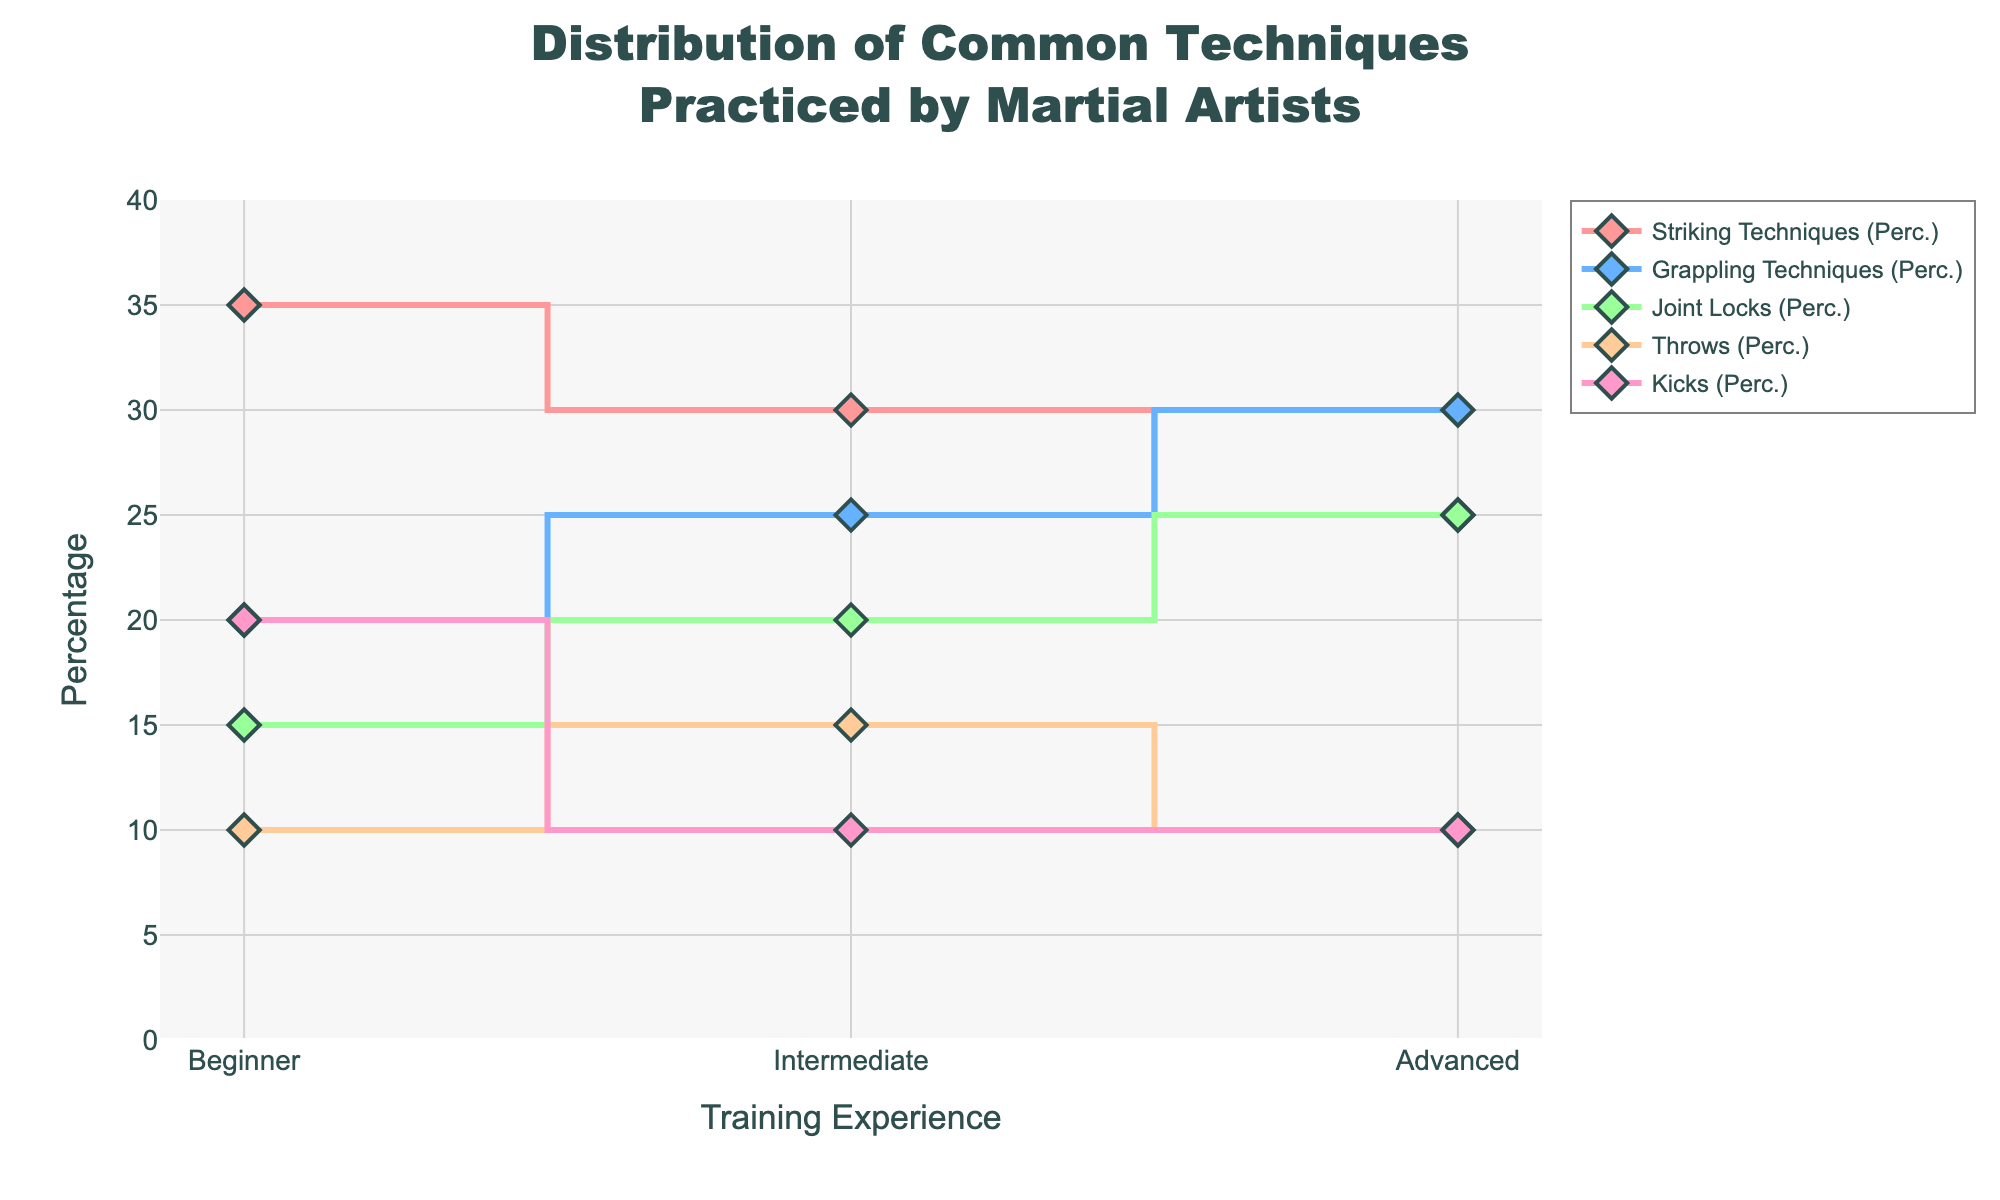What's the title of the figure? The title of the figure is displayed at the top and reads "Distribution of Common Techniques Practiced by Martial Artists". The text is centered and bold for emphasis.
Answer: Distribution of Common Techniques Practiced by Martial Artists What is the percentage of Striking Techniques practiced by Intermediate martial artists? Look at the data point for Intermediate on the Striking Techniques line indicated by its color. The point is at 30%.
Answer: 30% Which technique is practiced the least by beginners? Check the y-values for beginners (x = Beginner) and find the smallest percentage. Throws have the smallest at 10%.
Answer: Throws How do the percentages of Grappling Techniques compare between Intermediate and Advanced levels? Check the percentages of Grappling Techniques for Intermediate (25%) and Advanced (30%). 30% is larger than 25%.
Answer: Advanced practices more What is the range of Joint Locks percentages across all training experiences? The smallest percentage for Joint Locks is 15% (Beginner), and the largest is 25% (Advanced and Intermediate). The range is 25% - 15% = 10%.
Answer: 10% What's the average percentage of Kicks for all training experiences? Calculate the average of the Kicks percentages: (20% + 10% + 10%) / 3 = 40% / 3 = 13.33%.
Answer: 13.33% How does the distribution of Throws change from Beginner to Intermediate levels? Look at the data points for Throws at Beginner (10%) and Intermediate (15%). Throws increase by 5%.
Answer: Increases by 5% Which technique remains constant from Intermediate to Advanced levels? Compare percentages for each technique from Intermediate to Advanced. Throws remain at 10%.
Answer: Throws What is the difference in the percentage of Joint Locks from Beginner to Advanced levels? Joint Locks are 15% for Beginners and 25% for Advanced. The difference is 25% - 15% = 10%.
Answer: 10% Which technique shows the largest percentage increase from Beginner to Advanced? For each technique, calculate the difference in percentages from Beginner to Advanced. Joint Locks increase the most, by 10%.
Answer: Joint Locks 